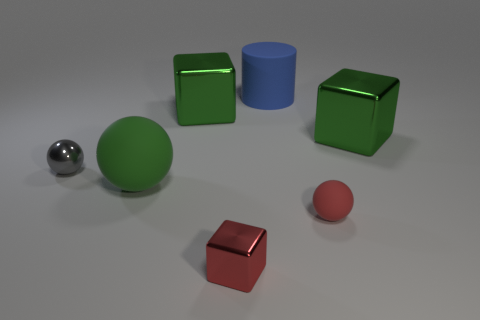Compare the sizes of the green spherical object and the red cube. The green spherical object is larger in scale compared to the red cube. The sphere's increased size is evident when they are compared within the spatial context provided by their placement in the scene. 